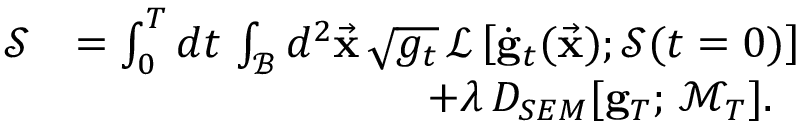Convert formula to latex. <formula><loc_0><loc_0><loc_500><loc_500>\begin{array} { r l } { \mathcal { S } } & { = \int _ { 0 } ^ { T } d t \, \int _ { \mathcal { B } } d ^ { 2 } \vec { x } \, \sqrt { g _ { t } } \, \mathcal { L } \left [ \dot { g } _ { t } ( \vec { x } ) ; \mathcal { S } ( t = 0 ) \right ] } \\ & { \quad + \lambda \, D _ { S E M } [ { g } _ { T } ; \, \mathcal { M } _ { T } ] . } \end{array}</formula> 